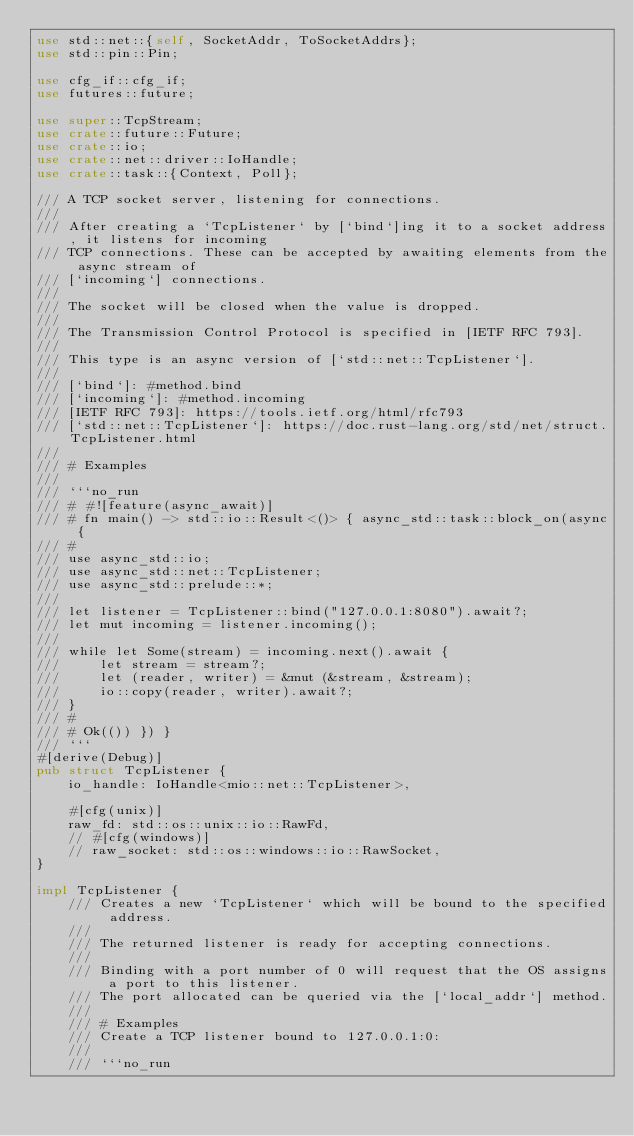Convert code to text. <code><loc_0><loc_0><loc_500><loc_500><_Rust_>use std::net::{self, SocketAddr, ToSocketAddrs};
use std::pin::Pin;

use cfg_if::cfg_if;
use futures::future;

use super::TcpStream;
use crate::future::Future;
use crate::io;
use crate::net::driver::IoHandle;
use crate::task::{Context, Poll};

/// A TCP socket server, listening for connections.
///
/// After creating a `TcpListener` by [`bind`]ing it to a socket address, it listens for incoming
/// TCP connections. These can be accepted by awaiting elements from the async stream of
/// [`incoming`] connections.
///
/// The socket will be closed when the value is dropped.
///
/// The Transmission Control Protocol is specified in [IETF RFC 793].
///
/// This type is an async version of [`std::net::TcpListener`].
///
/// [`bind`]: #method.bind
/// [`incoming`]: #method.incoming
/// [IETF RFC 793]: https://tools.ietf.org/html/rfc793
/// [`std::net::TcpListener`]: https://doc.rust-lang.org/std/net/struct.TcpListener.html
///
/// # Examples
///
/// ```no_run
/// # #![feature(async_await)]
/// # fn main() -> std::io::Result<()> { async_std::task::block_on(async {
/// #
/// use async_std::io;
/// use async_std::net::TcpListener;
/// use async_std::prelude::*;
///
/// let listener = TcpListener::bind("127.0.0.1:8080").await?;
/// let mut incoming = listener.incoming();
///
/// while let Some(stream) = incoming.next().await {
///     let stream = stream?;
///     let (reader, writer) = &mut (&stream, &stream);
///     io::copy(reader, writer).await?;
/// }
/// #
/// # Ok(()) }) }
/// ```
#[derive(Debug)]
pub struct TcpListener {
    io_handle: IoHandle<mio::net::TcpListener>,

    #[cfg(unix)]
    raw_fd: std::os::unix::io::RawFd,
    // #[cfg(windows)]
    // raw_socket: std::os::windows::io::RawSocket,
}

impl TcpListener {
    /// Creates a new `TcpListener` which will be bound to the specified address.
    ///
    /// The returned listener is ready for accepting connections.
    ///
    /// Binding with a port number of 0 will request that the OS assigns a port to this listener.
    /// The port allocated can be queried via the [`local_addr`] method.
    ///
    /// # Examples
    /// Create a TCP listener bound to 127.0.0.1:0:
    ///
    /// ```no_run</code> 